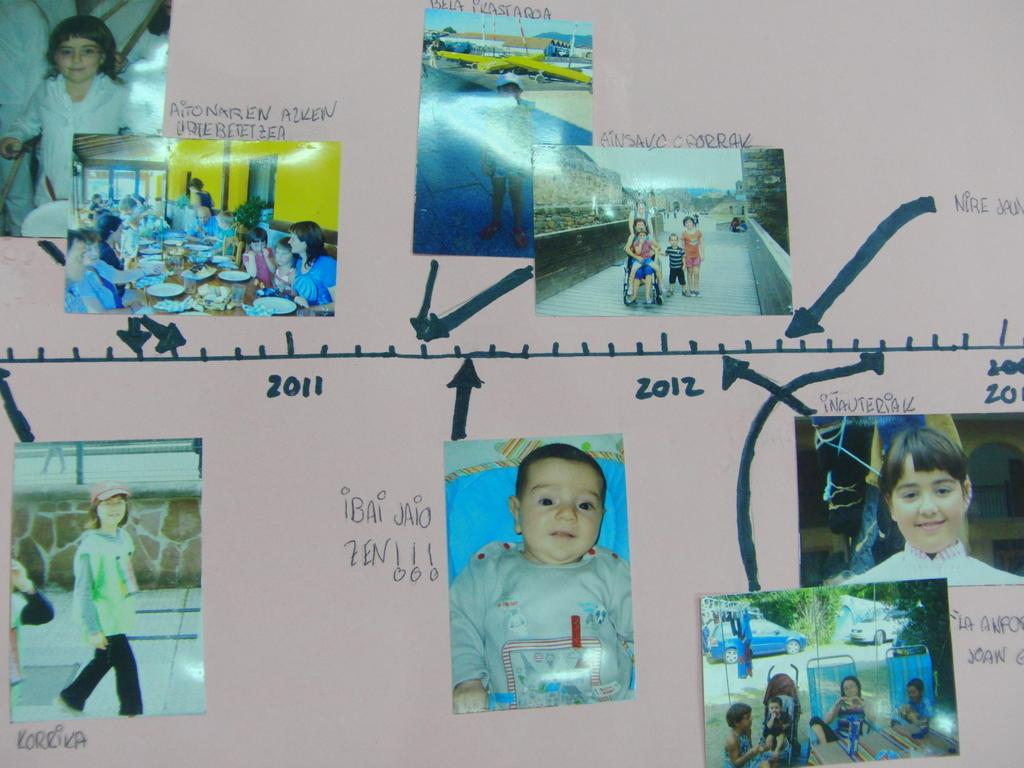What is displayed on the board in the image? There are photos of persons, sketch lines, texts, and numbers on the board. Can you describe the photos of persons on the board? The photos of persons on the board are likely portraits or images of individuals. What type of markings are present on the board besides the photos? There are sketch lines, texts, and numbers on the board. What type of gold jewelry is the crow wearing in the image? There is no crow or gold jewelry present in the image; it only features a board with photos, sketch lines, texts, and numbers. 